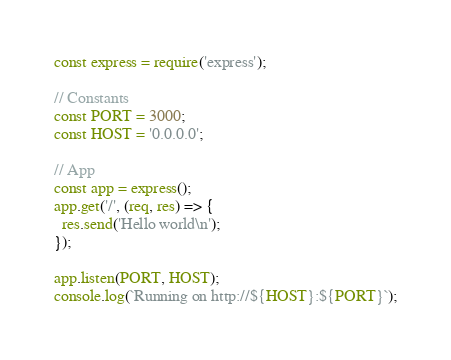<code> <loc_0><loc_0><loc_500><loc_500><_JavaScript_>const express = require('express');

// Constants
const PORT = 3000;
const HOST = '0.0.0.0';

// App
const app = express();
app.get('/', (req, res) => {
  res.send('Hello world\n');
});

app.listen(PORT, HOST);
console.log(`Running on http://${HOST}:${PORT}`);</code> 